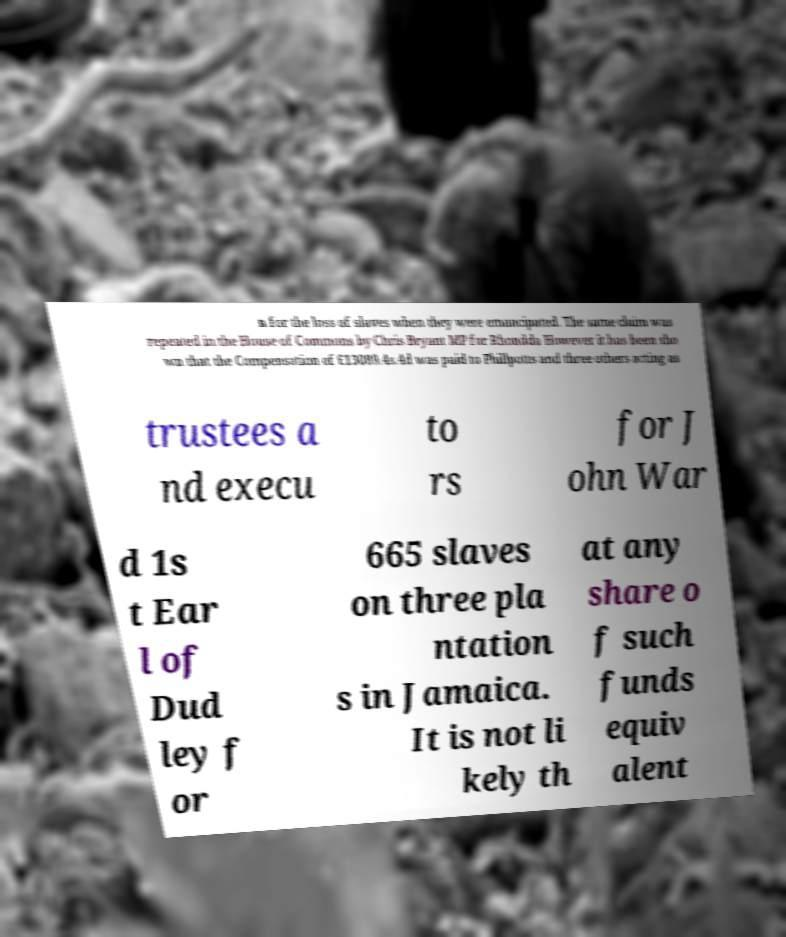Can you accurately transcribe the text from the provided image for me? n for the loss of slaves when they were emancipated. The same claim was repeated in the House of Commons by Chris Bryant MP for Rhondda However it has been sho wn that the Compensation of £13089.4s.4d was paid to Phillpotts and three others acting as trustees a nd execu to rs for J ohn War d 1s t Ear l of Dud ley f or 665 slaves on three pla ntation s in Jamaica. It is not li kely th at any share o f such funds equiv alent 